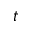<formula> <loc_0><loc_0><loc_500><loc_500>t</formula> 